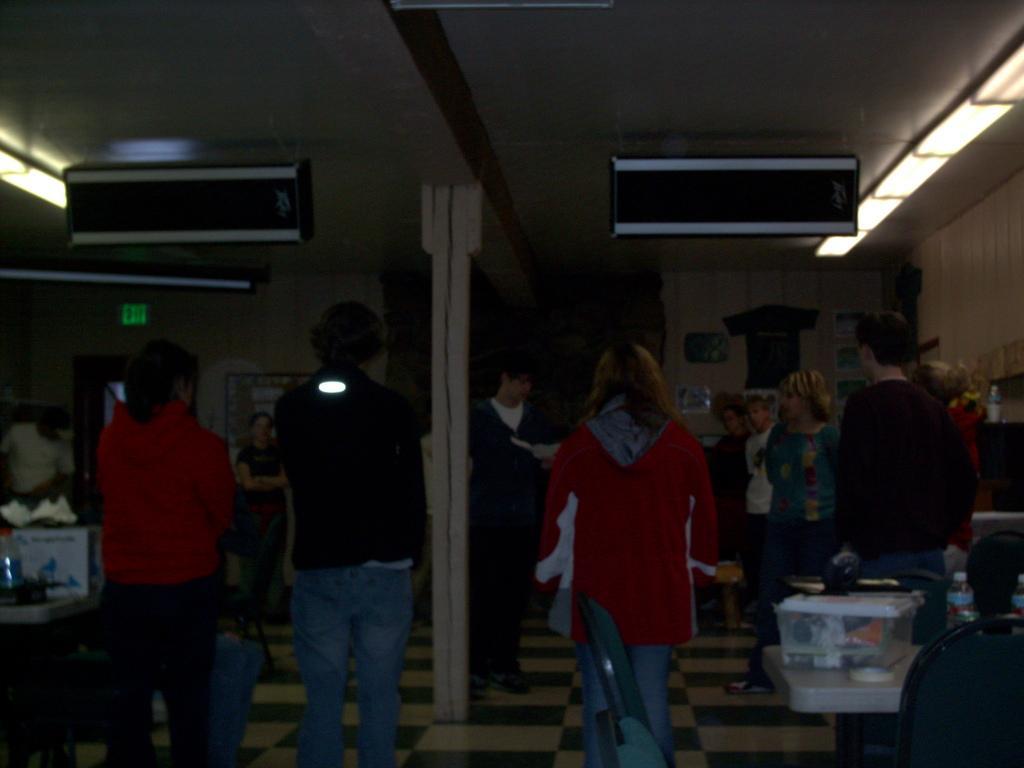Can you describe this image briefly? Here in this picture we can see number of men and women standing on the floor in a room and we can also see lights present on the roof and we can see speakers present on the roof and we can see tables with somethings pressing on it. 